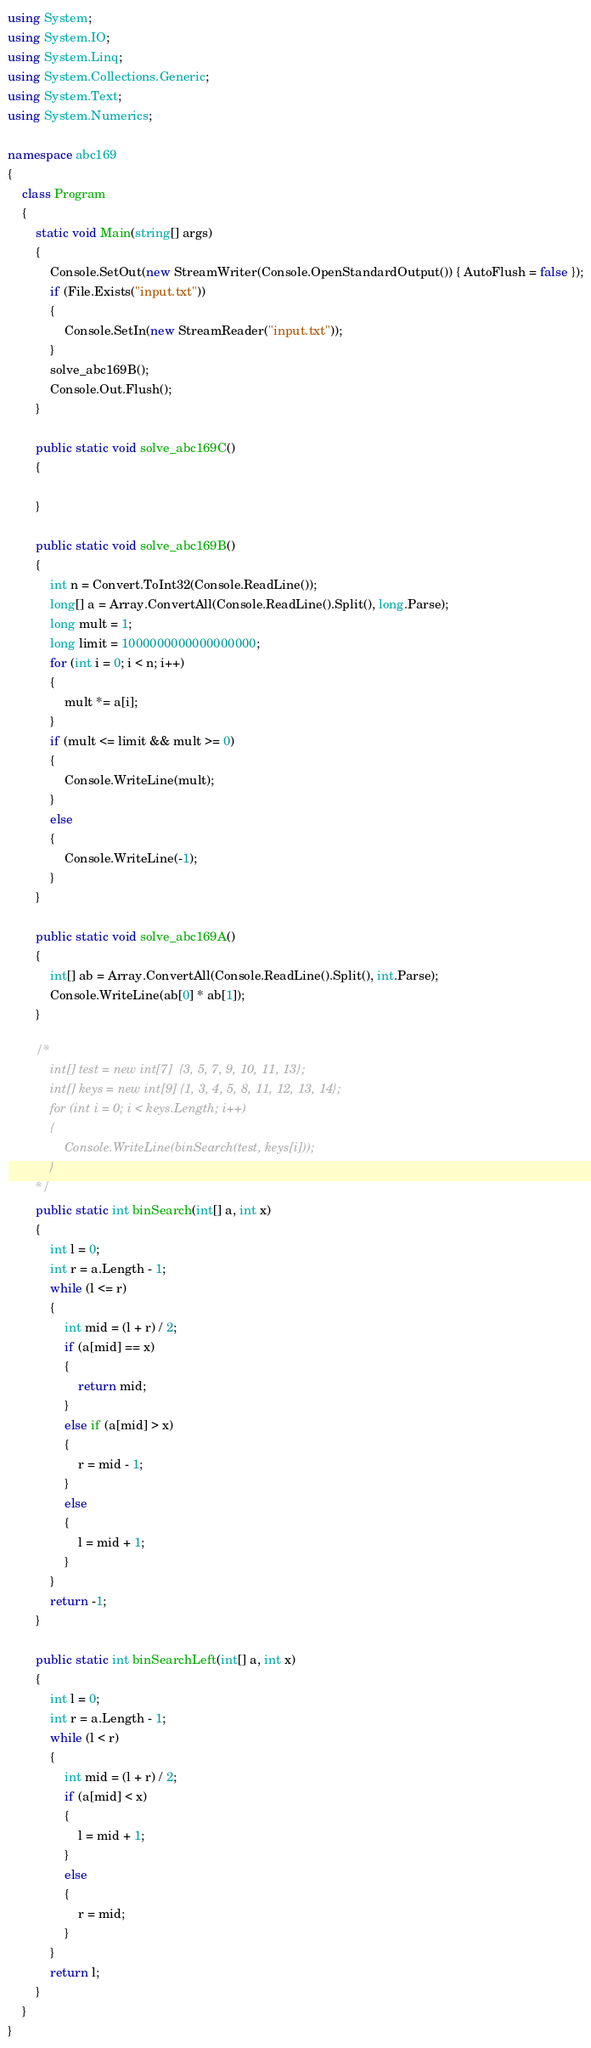<code> <loc_0><loc_0><loc_500><loc_500><_C#_>using System;
using System.IO;
using System.Linq;
using System.Collections.Generic;
using System.Text;
using System.Numerics;

namespace abc169
{
    class Program
    {
        static void Main(string[] args)
        {
            Console.SetOut(new StreamWriter(Console.OpenStandardOutput()) { AutoFlush = false });
            if (File.Exists("input.txt"))
            {
                Console.SetIn(new StreamReader("input.txt"));
            }
            solve_abc169B();
            Console.Out.Flush();
        }

        public static void solve_abc169C()
        {
            
        }

        public static void solve_abc169B()
        {
            int n = Convert.ToInt32(Console.ReadLine());
            long[] a = Array.ConvertAll(Console.ReadLine().Split(), long.Parse);
            long mult = 1;
            long limit = 1000000000000000000;
            for (int i = 0; i < n; i++)
            {
                mult *= a[i];
            }
            if (mult <= limit && mult >= 0)
            {
                Console.WriteLine(mult);
            }
            else
            {
                Console.WriteLine(-1);
            }
        }

        public static void solve_abc169A()
        {
            int[] ab = Array.ConvertAll(Console.ReadLine().Split(), int.Parse);
            Console.WriteLine(ab[0] * ab[1]);
        }

        /*
            int[] test = new int[7]  {3, 5, 7, 9, 10, 11, 13};
            int[] keys = new int[9] {1, 3, 4, 5, 8, 11, 12, 13, 14};
            for (int i = 0; i < keys.Length; i++)
            {
                Console.WriteLine(binSearch(test, keys[i]));
            }
        */
        public static int binSearch(int[] a, int x)
        {
            int l = 0;
            int r = a.Length - 1;
            while (l <= r)
            {
                int mid = (l + r) / 2;
                if (a[mid] == x)
                {
                    return mid;
                }
                else if (a[mid] > x)
                {
                    r = mid - 1;
                }
                else
                {
                    l = mid + 1;
                }
            }
            return -1;
        }

        public static int binSearchLeft(int[] a, int x)
        {
            int l = 0;
            int r = a.Length - 1;
            while (l < r)
            {
                int mid = (l + r) / 2;
                if (a[mid] < x)
                {
                    l = mid + 1;
                }
                else
                {
                    r = mid;
                }
            }
            return l;
        }
    }
}</code> 